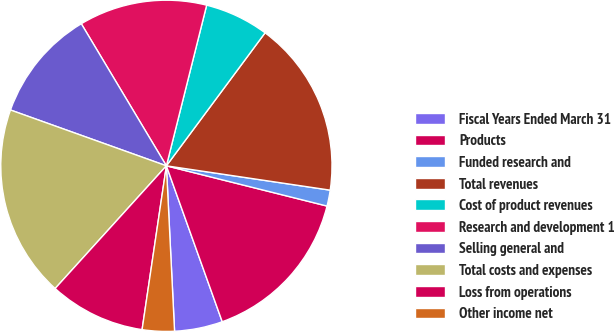Convert chart to OTSL. <chart><loc_0><loc_0><loc_500><loc_500><pie_chart><fcel>Fiscal Years Ended March 31<fcel>Products<fcel>Funded research and<fcel>Total revenues<fcel>Cost of product revenues<fcel>Research and development 1<fcel>Selling general and<fcel>Total costs and expenses<fcel>Loss from operations<fcel>Other income net<nl><fcel>4.69%<fcel>15.62%<fcel>1.56%<fcel>17.19%<fcel>6.25%<fcel>12.5%<fcel>10.94%<fcel>18.75%<fcel>9.38%<fcel>3.13%<nl></chart> 